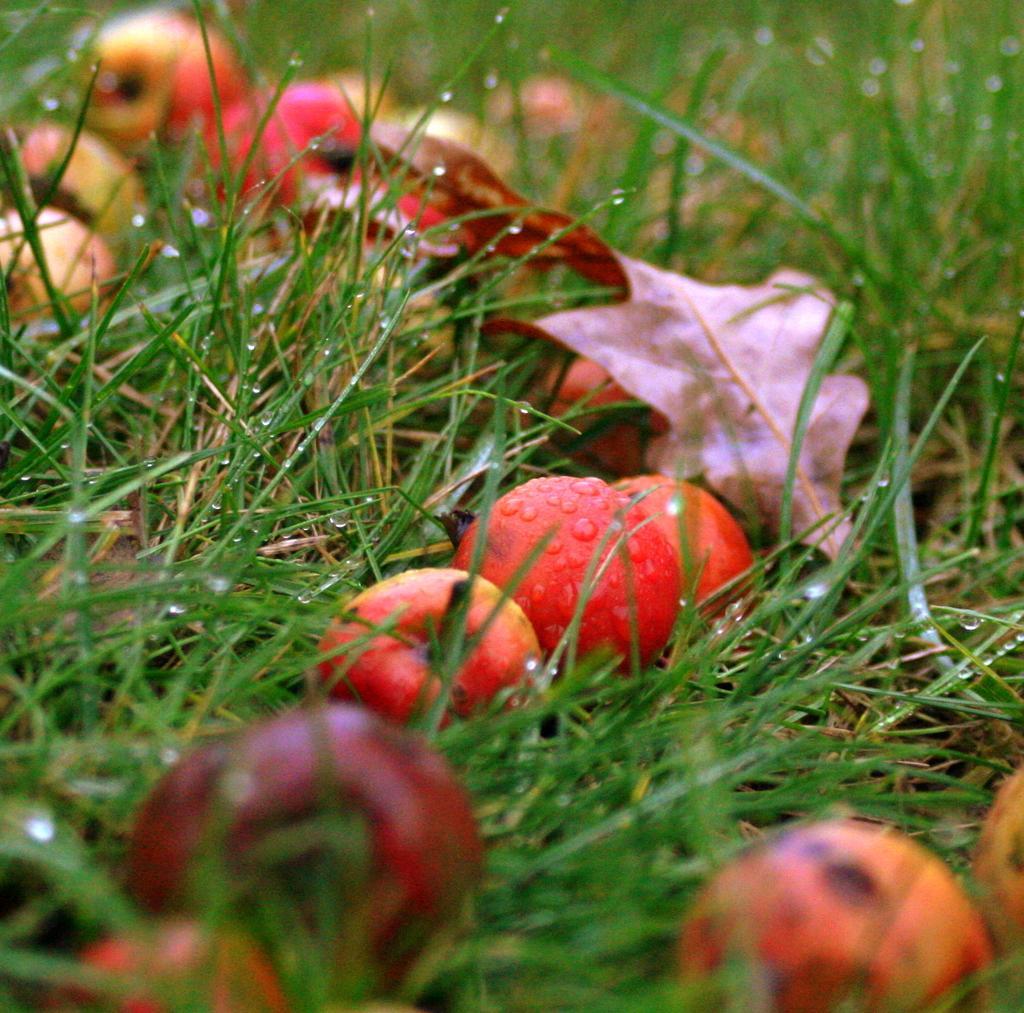How would you summarize this image in a sentence or two? In this picture I can see some fruits and the grass. 